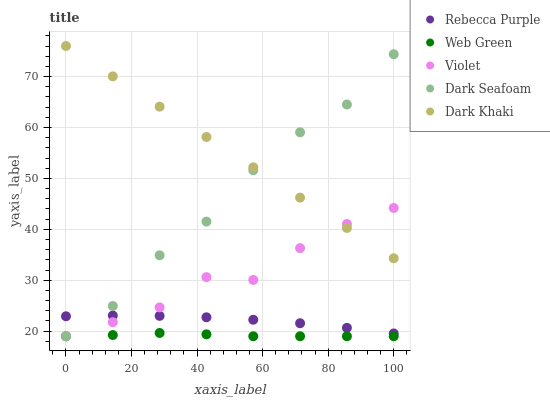Does Web Green have the minimum area under the curve?
Answer yes or no. Yes. Does Dark Khaki have the maximum area under the curve?
Answer yes or no. Yes. Does Dark Seafoam have the minimum area under the curve?
Answer yes or no. No. Does Dark Seafoam have the maximum area under the curve?
Answer yes or no. No. Is Dark Khaki the smoothest?
Answer yes or no. Yes. Is Dark Seafoam the roughest?
Answer yes or no. Yes. Is Rebecca Purple the smoothest?
Answer yes or no. No. Is Rebecca Purple the roughest?
Answer yes or no. No. Does Dark Seafoam have the lowest value?
Answer yes or no. Yes. Does Rebecca Purple have the lowest value?
Answer yes or no. No. Does Dark Khaki have the highest value?
Answer yes or no. Yes. Does Dark Seafoam have the highest value?
Answer yes or no. No. Is Web Green less than Dark Khaki?
Answer yes or no. Yes. Is Rebecca Purple greater than Web Green?
Answer yes or no. Yes. Does Rebecca Purple intersect Dark Seafoam?
Answer yes or no. Yes. Is Rebecca Purple less than Dark Seafoam?
Answer yes or no. No. Is Rebecca Purple greater than Dark Seafoam?
Answer yes or no. No. Does Web Green intersect Dark Khaki?
Answer yes or no. No. 